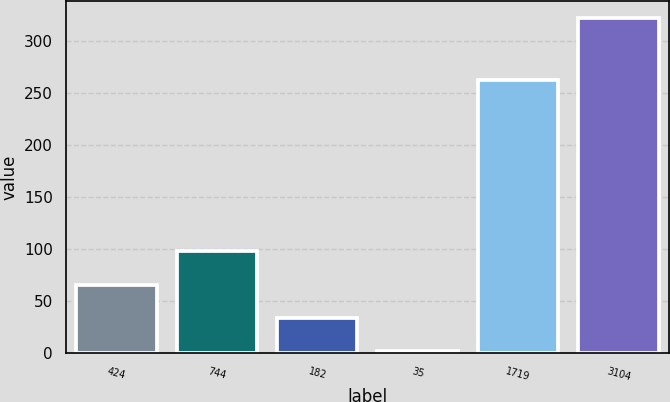<chart> <loc_0><loc_0><loc_500><loc_500><bar_chart><fcel>424<fcel>744<fcel>182<fcel>35<fcel>1719<fcel>3104<nl><fcel>65.64<fcel>97.66<fcel>33.62<fcel>1.6<fcel>262.4<fcel>321.8<nl></chart> 